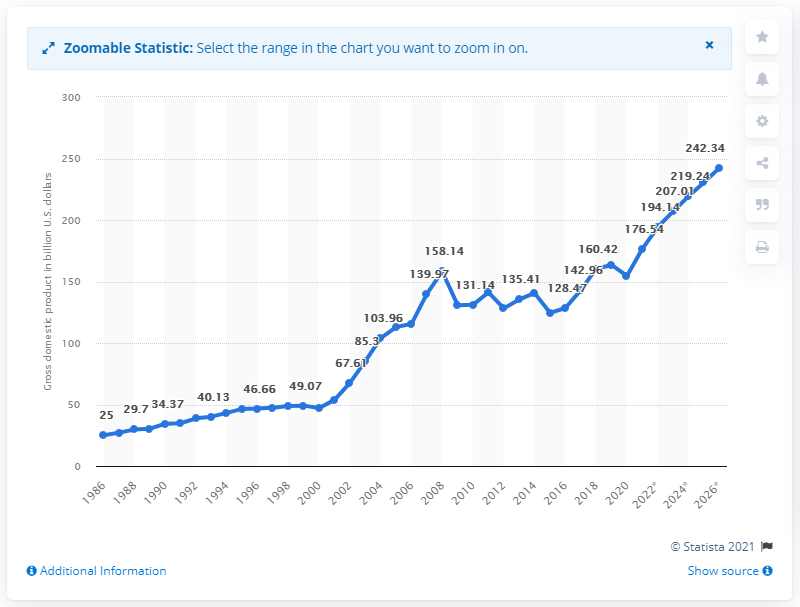Specify some key components in this picture. In 2020, Hungary's gross domestic product was estimated to be 154.56 billion dollars. 